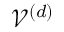Convert formula to latex. <formula><loc_0><loc_0><loc_500><loc_500>\mathcal { V } ^ { ( d ) }</formula> 